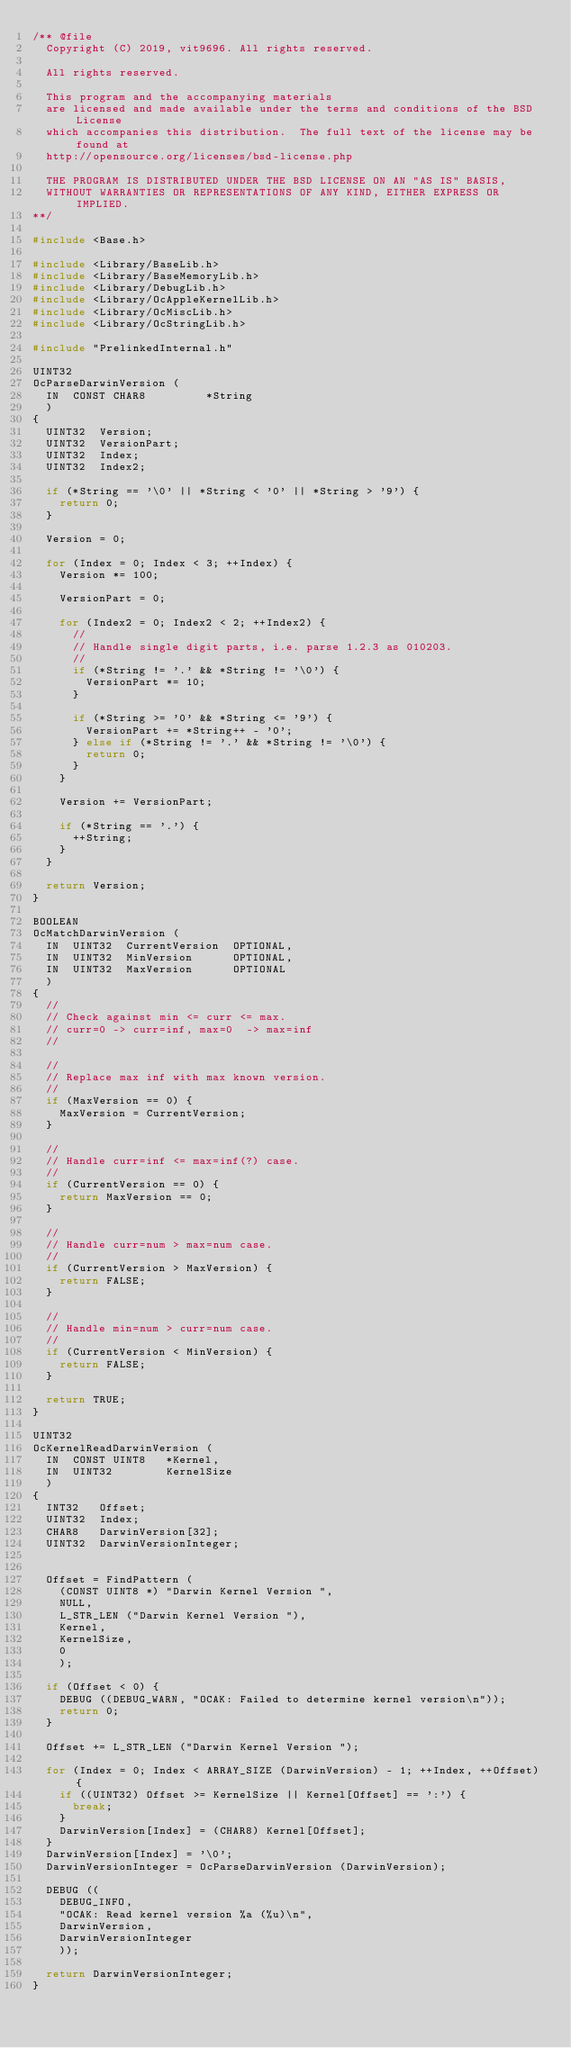<code> <loc_0><loc_0><loc_500><loc_500><_C_>/** @file
  Copyright (C) 2019, vit9696. All rights reserved.

  All rights reserved.

  This program and the accompanying materials
  are licensed and made available under the terms and conditions of the BSD License
  which accompanies this distribution.  The full text of the license may be found at
  http://opensource.org/licenses/bsd-license.php

  THE PROGRAM IS DISTRIBUTED UNDER THE BSD LICENSE ON AN "AS IS" BASIS,
  WITHOUT WARRANTIES OR REPRESENTATIONS OF ANY KIND, EITHER EXPRESS OR IMPLIED.
**/

#include <Base.h>

#include <Library/BaseLib.h>
#include <Library/BaseMemoryLib.h>
#include <Library/DebugLib.h>
#include <Library/OcAppleKernelLib.h>
#include <Library/OcMiscLib.h>
#include <Library/OcStringLib.h>

#include "PrelinkedInternal.h"

UINT32
OcParseDarwinVersion (
  IN  CONST CHAR8         *String
  )
{
  UINT32  Version;
  UINT32  VersionPart;
  UINT32  Index;
  UINT32  Index2;

  if (*String == '\0' || *String < '0' || *String > '9') {
    return 0;
  }

  Version = 0;

  for (Index = 0; Index < 3; ++Index) {
    Version *= 100;

    VersionPart = 0;

    for (Index2 = 0; Index2 < 2; ++Index2) {
      //
      // Handle single digit parts, i.e. parse 1.2.3 as 010203.
      //
      if (*String != '.' && *String != '\0') {
        VersionPart *= 10;
      }

      if (*String >= '0' && *String <= '9') {
        VersionPart += *String++ - '0';
      } else if (*String != '.' && *String != '\0') {
        return 0;
      }
    }

    Version += VersionPart;

    if (*String == '.') {
      ++String;
    }
  }

  return Version;
}

BOOLEAN
OcMatchDarwinVersion (
  IN  UINT32  CurrentVersion  OPTIONAL,
  IN  UINT32  MinVersion      OPTIONAL,
  IN  UINT32  MaxVersion      OPTIONAL
  )
{
  //
  // Check against min <= curr <= max.
  // curr=0 -> curr=inf, max=0  -> max=inf
  //

  //
  // Replace max inf with max known version.
  //
  if (MaxVersion == 0) {
    MaxVersion = CurrentVersion;
  }

  //
  // Handle curr=inf <= max=inf(?) case.
  //
  if (CurrentVersion == 0) {
    return MaxVersion == 0;
  }

  //
  // Handle curr=num > max=num case.
  //
  if (CurrentVersion > MaxVersion) {
    return FALSE;
  }

  //
  // Handle min=num > curr=num case.
  //
  if (CurrentVersion < MinVersion) {
    return FALSE;
  }

  return TRUE;
}

UINT32
OcKernelReadDarwinVersion (
  IN  CONST UINT8   *Kernel,
  IN  UINT32        KernelSize
  )
{
  INT32   Offset;
  UINT32  Index;
  CHAR8   DarwinVersion[32];
  UINT32  DarwinVersionInteger;


  Offset = FindPattern (
    (CONST UINT8 *) "Darwin Kernel Version ",
    NULL,
    L_STR_LEN ("Darwin Kernel Version "),
    Kernel,
    KernelSize,
    0
    );

  if (Offset < 0) {
    DEBUG ((DEBUG_WARN, "OCAK: Failed to determine kernel version\n"));
    return 0;
  }

  Offset += L_STR_LEN ("Darwin Kernel Version ");

  for (Index = 0; Index < ARRAY_SIZE (DarwinVersion) - 1; ++Index, ++Offset) {
    if ((UINT32) Offset >= KernelSize || Kernel[Offset] == ':') {
      break;
    }
    DarwinVersion[Index] = (CHAR8) Kernel[Offset];
  }
  DarwinVersion[Index] = '\0';
  DarwinVersionInteger = OcParseDarwinVersion (DarwinVersion);

  DEBUG ((
    DEBUG_INFO,
    "OCAK: Read kernel version %a (%u)\n",
    DarwinVersion,
    DarwinVersionInteger
    ));

  return DarwinVersionInteger;
}
</code> 